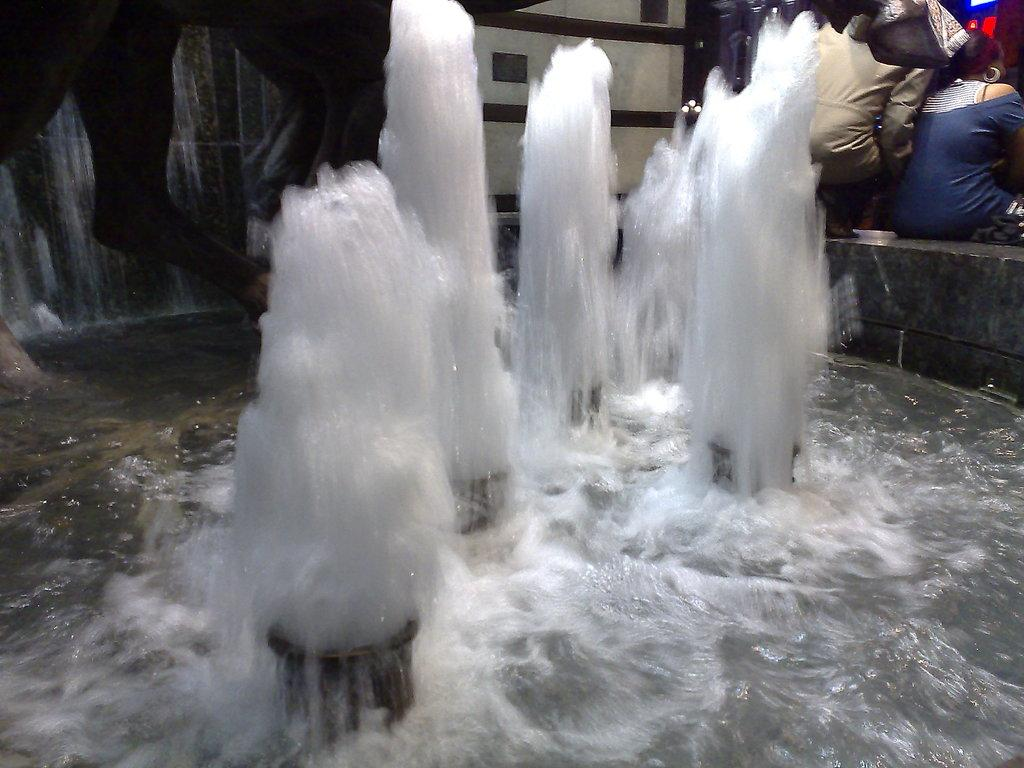What is the primary element visible in the image? There is water in the image. What else can be seen in the image besides the water? There is a wall and two persons sitting in the image. Can you describe the clothing of the woman sitting on the right side? The woman sitting on the right side is wearing a blue dress. How would you describe the lighting in the image? The image is a little dark. What type of donkey can be seen participating in the feast in the image? There is no donkey or feast present in the image. How many passengers are visible in the image? There are no passengers mentioned in the image; only two persons are sitting. 